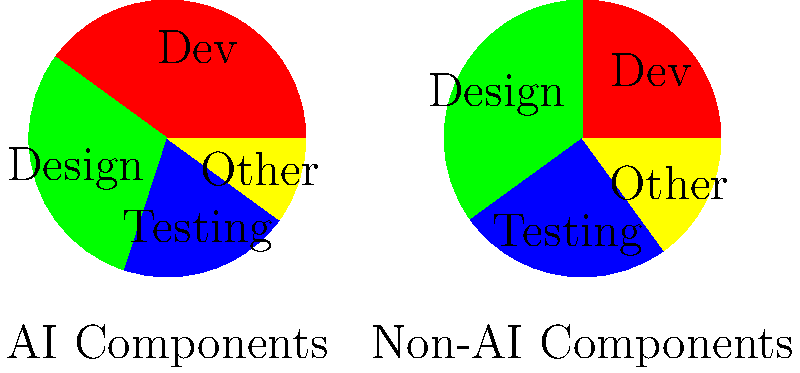As a project manager, you are analyzing the resource allocation for AI and non-AI components of a project. The pie charts show the distribution of resources for both components. What is the difference in percentage points between the Design allocation for AI components and non-AI components? To find the difference in percentage points between the Design allocation for AI and non-AI components, we need to:

1. Identify the Design allocation for AI components:
   From the left pie chart (AI Components), we can see that Design takes up 30% of the resources.

2. Identify the Design allocation for non-AI components:
   From the right pie chart (Non-AI Components), we can see that Design takes up 35% of the resources.

3. Calculate the difference:
   $35\% - 30\% = 5\%$

The difference in percentage points is 5. Note that we're calculating the absolute difference, so the order of subtraction doesn't matter in this case.

This analysis helps the project manager understand how resource allocation for design differs between AI and non-AI components, which can inform decisions about resource management and collaboration between designers and data scientists.
Answer: 5 percentage points 